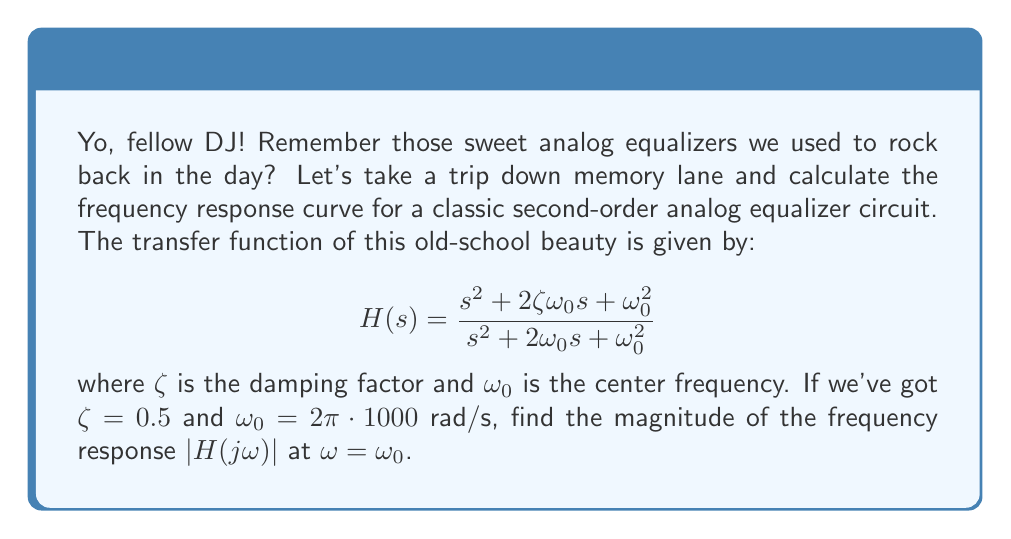Help me with this question. Alright, let's break this down step-by-step, just like we used to break down those funky beats:

1) First, we need to substitute $s$ with $j\omega$ in our transfer function:

   $$H(j\omega) = \frac{(j\omega)^2 + 2\zeta\omega_0(j\omega) + \omega_0^2}{(j\omega)^2 + 2\omega_0(j\omega) + \omega_0^2}$$

2) Now, we're interested in the magnitude at $\omega = \omega_0$, so let's make that substitution:

   $$H(j\omega_0) = \frac{(j\omega_0)^2 + 2\zeta\omega_0(j\omega_0) + \omega_0^2}{(j\omega_0)^2 + 2\omega_0(j\omega_0) + \omega_0^2}$$

3) Simplify the numerator and denominator:

   $$H(j\omega_0) = \frac{-\omega_0^2 + 2\zeta\omega_0^2j + \omega_0^2}{-\omega_0^2 + 2\omega_0^2j + \omega_0^2}$$

4) Factor out $\omega_0^2$:

   $$H(j\omega_0) = \frac{(-1 + 2\zeta j + 1)\omega_0^2}{(-1 + 2j + 1)\omega_0^2}$$

5) Simplify:

   $$H(j\omega_0) = \frac{2\zeta j}{2j} = \zeta$$

6) The magnitude is the absolute value of this complex number:

   $$|H(j\omega_0)| = |\zeta| = 0.5$$

And there you have it! The magnitude of the frequency response at the center frequency is equal to the damping factor.
Answer: $$|H(j\omega_0)| = 0.5$$ 